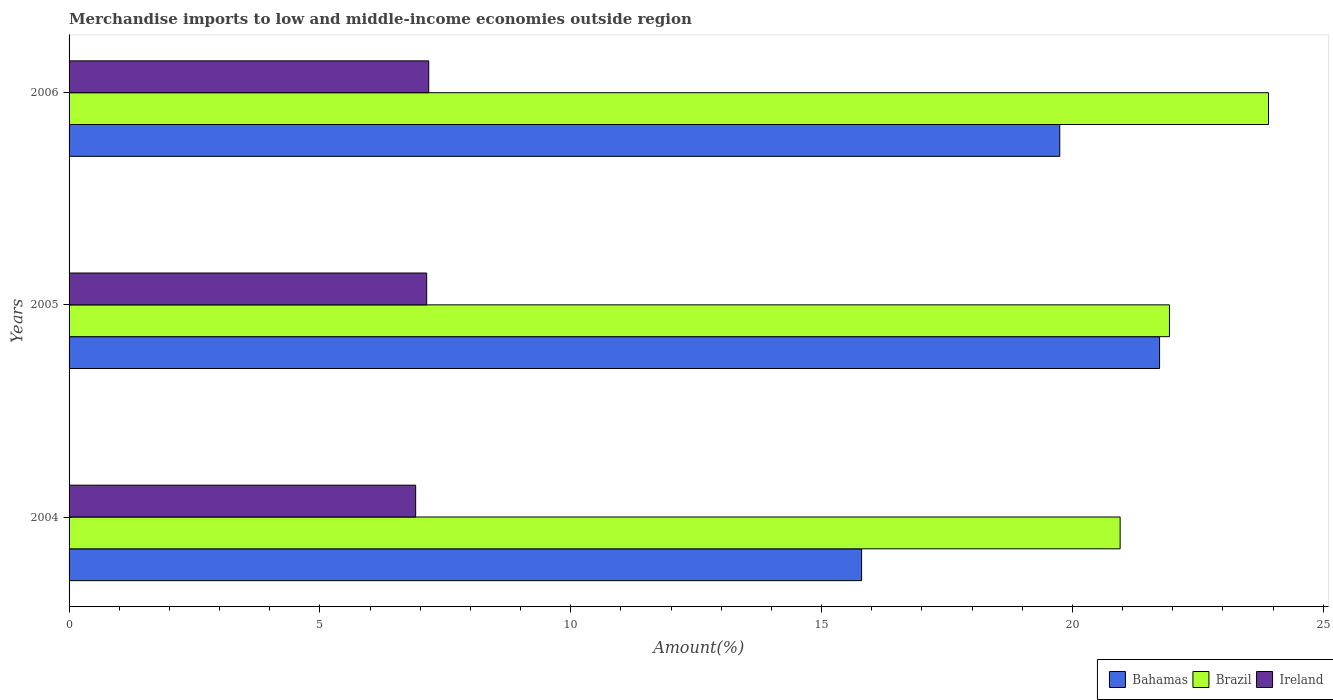How many different coloured bars are there?
Your answer should be very brief. 3. Are the number of bars per tick equal to the number of legend labels?
Give a very brief answer. Yes. How many bars are there on the 3rd tick from the top?
Offer a terse response. 3. What is the label of the 1st group of bars from the top?
Make the answer very short. 2006. What is the percentage of amount earned from merchandise imports in Ireland in 2005?
Offer a terse response. 7.13. Across all years, what is the maximum percentage of amount earned from merchandise imports in Bahamas?
Keep it short and to the point. 21.74. Across all years, what is the minimum percentage of amount earned from merchandise imports in Bahamas?
Your response must be concise. 15.8. In which year was the percentage of amount earned from merchandise imports in Ireland maximum?
Provide a short and direct response. 2006. What is the total percentage of amount earned from merchandise imports in Brazil in the graph?
Offer a terse response. 66.8. What is the difference between the percentage of amount earned from merchandise imports in Bahamas in 2005 and that in 2006?
Make the answer very short. 1.99. What is the difference between the percentage of amount earned from merchandise imports in Bahamas in 2006 and the percentage of amount earned from merchandise imports in Ireland in 2005?
Offer a terse response. 12.62. What is the average percentage of amount earned from merchandise imports in Bahamas per year?
Your answer should be compact. 19.1. In the year 2004, what is the difference between the percentage of amount earned from merchandise imports in Brazil and percentage of amount earned from merchandise imports in Ireland?
Offer a very short reply. 14.04. What is the ratio of the percentage of amount earned from merchandise imports in Bahamas in 2005 to that in 2006?
Your answer should be compact. 1.1. Is the difference between the percentage of amount earned from merchandise imports in Brazil in 2004 and 2005 greater than the difference between the percentage of amount earned from merchandise imports in Ireland in 2004 and 2005?
Your answer should be very brief. No. What is the difference between the highest and the second highest percentage of amount earned from merchandise imports in Bahamas?
Provide a succinct answer. 1.99. What is the difference between the highest and the lowest percentage of amount earned from merchandise imports in Brazil?
Offer a terse response. 2.96. What does the 3rd bar from the top in 2004 represents?
Give a very brief answer. Bahamas. What does the 1st bar from the bottom in 2005 represents?
Ensure brevity in your answer.  Bahamas. Are all the bars in the graph horizontal?
Offer a very short reply. Yes. How many years are there in the graph?
Provide a short and direct response. 3. Are the values on the major ticks of X-axis written in scientific E-notation?
Offer a very short reply. No. Does the graph contain grids?
Your answer should be very brief. No. Where does the legend appear in the graph?
Ensure brevity in your answer.  Bottom right. What is the title of the graph?
Your answer should be very brief. Merchandise imports to low and middle-income economies outside region. What is the label or title of the X-axis?
Provide a short and direct response. Amount(%). What is the Amount(%) in Bahamas in 2004?
Your answer should be compact. 15.8. What is the Amount(%) of Brazil in 2004?
Provide a short and direct response. 20.95. What is the Amount(%) in Ireland in 2004?
Offer a terse response. 6.91. What is the Amount(%) in Bahamas in 2005?
Offer a terse response. 21.74. What is the Amount(%) of Brazil in 2005?
Provide a succinct answer. 21.94. What is the Amount(%) of Ireland in 2005?
Keep it short and to the point. 7.13. What is the Amount(%) of Bahamas in 2006?
Your answer should be very brief. 19.75. What is the Amount(%) of Brazil in 2006?
Your response must be concise. 23.91. What is the Amount(%) of Ireland in 2006?
Your response must be concise. 7.17. Across all years, what is the maximum Amount(%) of Bahamas?
Keep it short and to the point. 21.74. Across all years, what is the maximum Amount(%) in Brazil?
Ensure brevity in your answer.  23.91. Across all years, what is the maximum Amount(%) in Ireland?
Ensure brevity in your answer.  7.17. Across all years, what is the minimum Amount(%) of Bahamas?
Provide a short and direct response. 15.8. Across all years, what is the minimum Amount(%) in Brazil?
Your response must be concise. 20.95. Across all years, what is the minimum Amount(%) in Ireland?
Provide a succinct answer. 6.91. What is the total Amount(%) in Bahamas in the graph?
Provide a short and direct response. 57.29. What is the total Amount(%) of Brazil in the graph?
Give a very brief answer. 66.8. What is the total Amount(%) of Ireland in the graph?
Offer a terse response. 21.21. What is the difference between the Amount(%) in Bahamas in 2004 and that in 2005?
Your answer should be very brief. -5.94. What is the difference between the Amount(%) of Brazil in 2004 and that in 2005?
Offer a terse response. -0.98. What is the difference between the Amount(%) of Ireland in 2004 and that in 2005?
Ensure brevity in your answer.  -0.22. What is the difference between the Amount(%) in Bahamas in 2004 and that in 2006?
Your response must be concise. -3.95. What is the difference between the Amount(%) in Brazil in 2004 and that in 2006?
Provide a succinct answer. -2.96. What is the difference between the Amount(%) in Ireland in 2004 and that in 2006?
Provide a short and direct response. -0.26. What is the difference between the Amount(%) in Bahamas in 2005 and that in 2006?
Provide a succinct answer. 1.99. What is the difference between the Amount(%) in Brazil in 2005 and that in 2006?
Your answer should be compact. -1.97. What is the difference between the Amount(%) in Ireland in 2005 and that in 2006?
Provide a short and direct response. -0.04. What is the difference between the Amount(%) in Bahamas in 2004 and the Amount(%) in Brazil in 2005?
Make the answer very short. -6.14. What is the difference between the Amount(%) in Bahamas in 2004 and the Amount(%) in Ireland in 2005?
Offer a terse response. 8.67. What is the difference between the Amount(%) in Brazil in 2004 and the Amount(%) in Ireland in 2005?
Make the answer very short. 13.82. What is the difference between the Amount(%) of Bahamas in 2004 and the Amount(%) of Brazil in 2006?
Your answer should be compact. -8.11. What is the difference between the Amount(%) in Bahamas in 2004 and the Amount(%) in Ireland in 2006?
Make the answer very short. 8.63. What is the difference between the Amount(%) in Brazil in 2004 and the Amount(%) in Ireland in 2006?
Your answer should be very brief. 13.78. What is the difference between the Amount(%) of Bahamas in 2005 and the Amount(%) of Brazil in 2006?
Give a very brief answer. -2.17. What is the difference between the Amount(%) in Bahamas in 2005 and the Amount(%) in Ireland in 2006?
Make the answer very short. 14.57. What is the difference between the Amount(%) in Brazil in 2005 and the Amount(%) in Ireland in 2006?
Your answer should be very brief. 14.77. What is the average Amount(%) of Bahamas per year?
Your answer should be compact. 19.1. What is the average Amount(%) in Brazil per year?
Provide a short and direct response. 22.27. What is the average Amount(%) in Ireland per year?
Provide a short and direct response. 7.07. In the year 2004, what is the difference between the Amount(%) in Bahamas and Amount(%) in Brazil?
Your answer should be compact. -5.15. In the year 2004, what is the difference between the Amount(%) in Bahamas and Amount(%) in Ireland?
Provide a succinct answer. 8.89. In the year 2004, what is the difference between the Amount(%) in Brazil and Amount(%) in Ireland?
Your answer should be compact. 14.04. In the year 2005, what is the difference between the Amount(%) in Bahamas and Amount(%) in Brazil?
Your answer should be compact. -0.2. In the year 2005, what is the difference between the Amount(%) of Bahamas and Amount(%) of Ireland?
Provide a succinct answer. 14.61. In the year 2005, what is the difference between the Amount(%) in Brazil and Amount(%) in Ireland?
Make the answer very short. 14.81. In the year 2006, what is the difference between the Amount(%) of Bahamas and Amount(%) of Brazil?
Provide a succinct answer. -4.16. In the year 2006, what is the difference between the Amount(%) in Bahamas and Amount(%) in Ireland?
Make the answer very short. 12.58. In the year 2006, what is the difference between the Amount(%) of Brazil and Amount(%) of Ireland?
Offer a terse response. 16.74. What is the ratio of the Amount(%) in Bahamas in 2004 to that in 2005?
Make the answer very short. 0.73. What is the ratio of the Amount(%) in Brazil in 2004 to that in 2005?
Your answer should be very brief. 0.96. What is the ratio of the Amount(%) of Ireland in 2004 to that in 2005?
Provide a succinct answer. 0.97. What is the ratio of the Amount(%) of Bahamas in 2004 to that in 2006?
Provide a succinct answer. 0.8. What is the ratio of the Amount(%) in Brazil in 2004 to that in 2006?
Offer a terse response. 0.88. What is the ratio of the Amount(%) of Ireland in 2004 to that in 2006?
Your response must be concise. 0.96. What is the ratio of the Amount(%) in Bahamas in 2005 to that in 2006?
Offer a very short reply. 1.1. What is the ratio of the Amount(%) of Brazil in 2005 to that in 2006?
Offer a terse response. 0.92. What is the difference between the highest and the second highest Amount(%) of Bahamas?
Keep it short and to the point. 1.99. What is the difference between the highest and the second highest Amount(%) in Brazil?
Your response must be concise. 1.97. What is the difference between the highest and the second highest Amount(%) of Ireland?
Offer a very short reply. 0.04. What is the difference between the highest and the lowest Amount(%) of Bahamas?
Give a very brief answer. 5.94. What is the difference between the highest and the lowest Amount(%) in Brazil?
Your answer should be compact. 2.96. What is the difference between the highest and the lowest Amount(%) of Ireland?
Give a very brief answer. 0.26. 